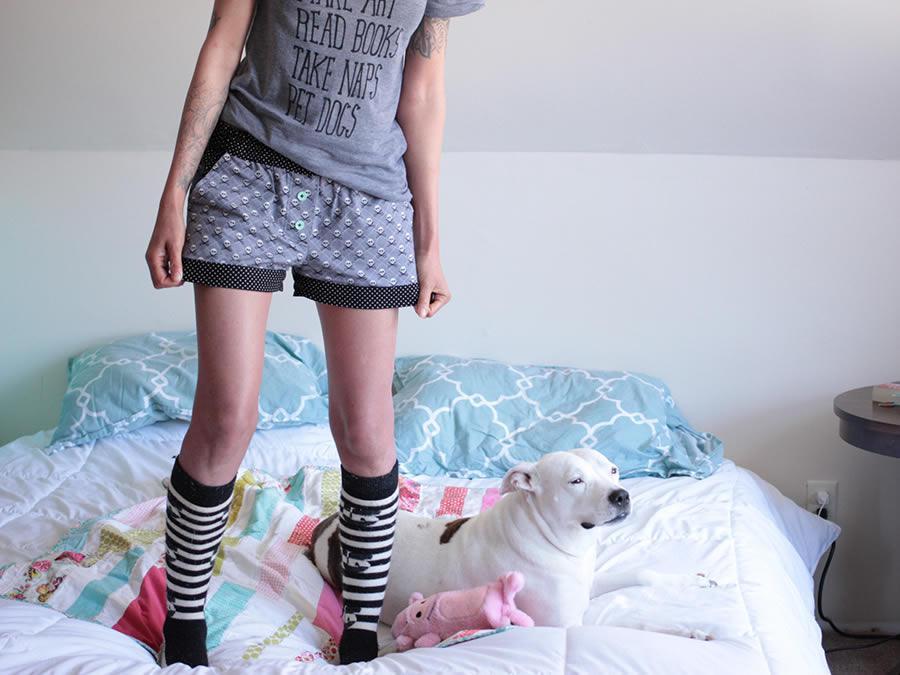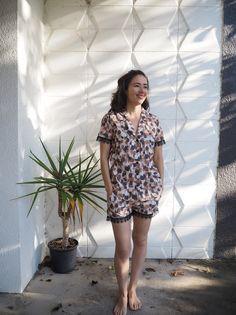The first image is the image on the left, the second image is the image on the right. Analyze the images presented: Is the assertion "One image shows sleepwear displayed flat on a surface, instead of modeled by a person." valid? Answer yes or no. No. The first image is the image on the left, the second image is the image on the right. Considering the images on both sides, is "A plant stands in the corner behind and to the left of a woman standing with hands in her pockets." valid? Answer yes or no. Yes. 